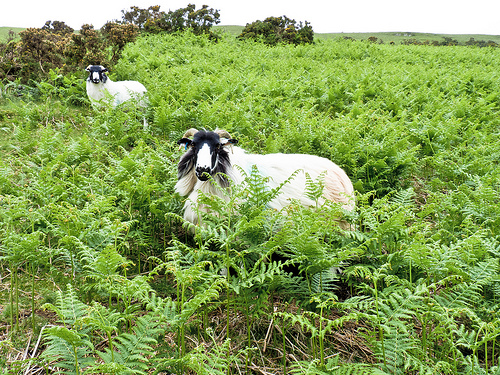Describe how the weather conditions might be affecting the scene depicted. The overcast sky suggests a cool and humid climate, likely contributing to the lush greenery visible. Such conditions are ideal for ferns and support healthy pasture for grazing. 